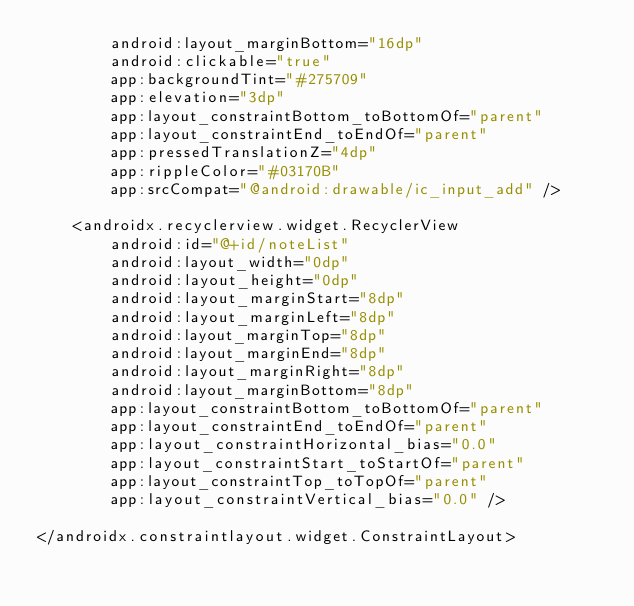Convert code to text. <code><loc_0><loc_0><loc_500><loc_500><_XML_>        android:layout_marginBottom="16dp"
        android:clickable="true"
        app:backgroundTint="#275709"
        app:elevation="3dp"
        app:layout_constraintBottom_toBottomOf="parent"
        app:layout_constraintEnd_toEndOf="parent"
        app:pressedTranslationZ="4dp"
        app:rippleColor="#03170B"
        app:srcCompat="@android:drawable/ic_input_add" />

    <androidx.recyclerview.widget.RecyclerView
        android:id="@+id/noteList"
        android:layout_width="0dp"
        android:layout_height="0dp"
        android:layout_marginStart="8dp"
        android:layout_marginLeft="8dp"
        android:layout_marginTop="8dp"
        android:layout_marginEnd="8dp"
        android:layout_marginRight="8dp"
        android:layout_marginBottom="8dp"
        app:layout_constraintBottom_toBottomOf="parent"
        app:layout_constraintEnd_toEndOf="parent"
        app:layout_constraintHorizontal_bias="0.0"
        app:layout_constraintStart_toStartOf="parent"
        app:layout_constraintTop_toTopOf="parent"
        app:layout_constraintVertical_bias="0.0" />

</androidx.constraintlayout.widget.ConstraintLayout></code> 